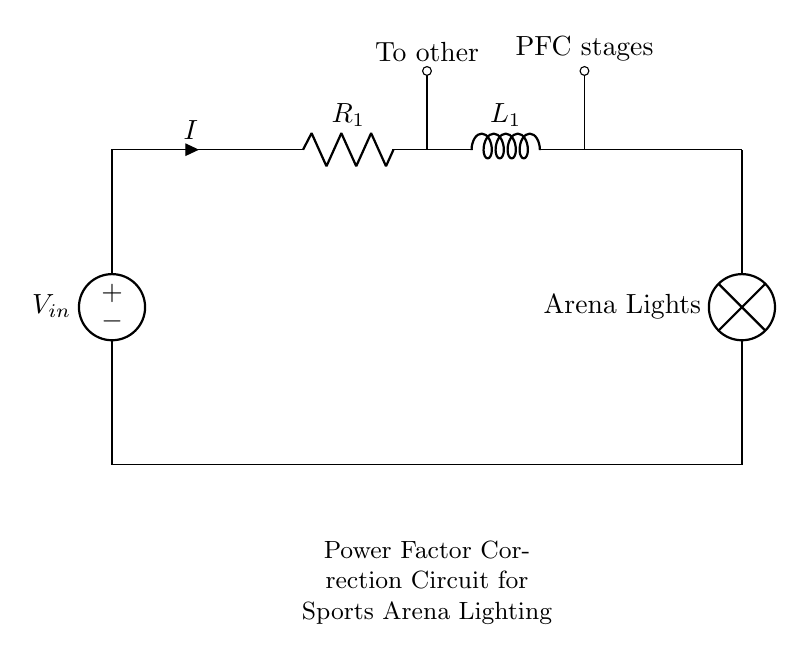What type of component is used to correct the power factor? The circuit includes an inductor, which is often employed in power factor correction to counteract the inductance of loads.
Answer: Inductor What is the connection type between the resistor and the inductor? The resistor and inductor are connected in series as indicated by their sequential arrangement on the same line in the circuit diagram.
Answer: Series What is the purpose of the power factor correction circuit? The circuit aims to improve the power factor for more efficient operation of the lighting system by eliminating reactive power.
Answer: Improve efficiency How many pathways are there from the power source to the arena lights? There is one pathway that connects the power source through the resistor and inductor in series to the arena lights.
Answer: One What is the label given to the output of the inductor? The output of the inductor in this circuit is labeled as 'PFC stages,' indicating its role in power factor correction.
Answer: PFC stages What is the symbol used to represent the arena lights in the circuit? The arena lights are represented as a lamp symbol, which is commonly used in circuits to denote lighting elements.
Answer: Lamp 